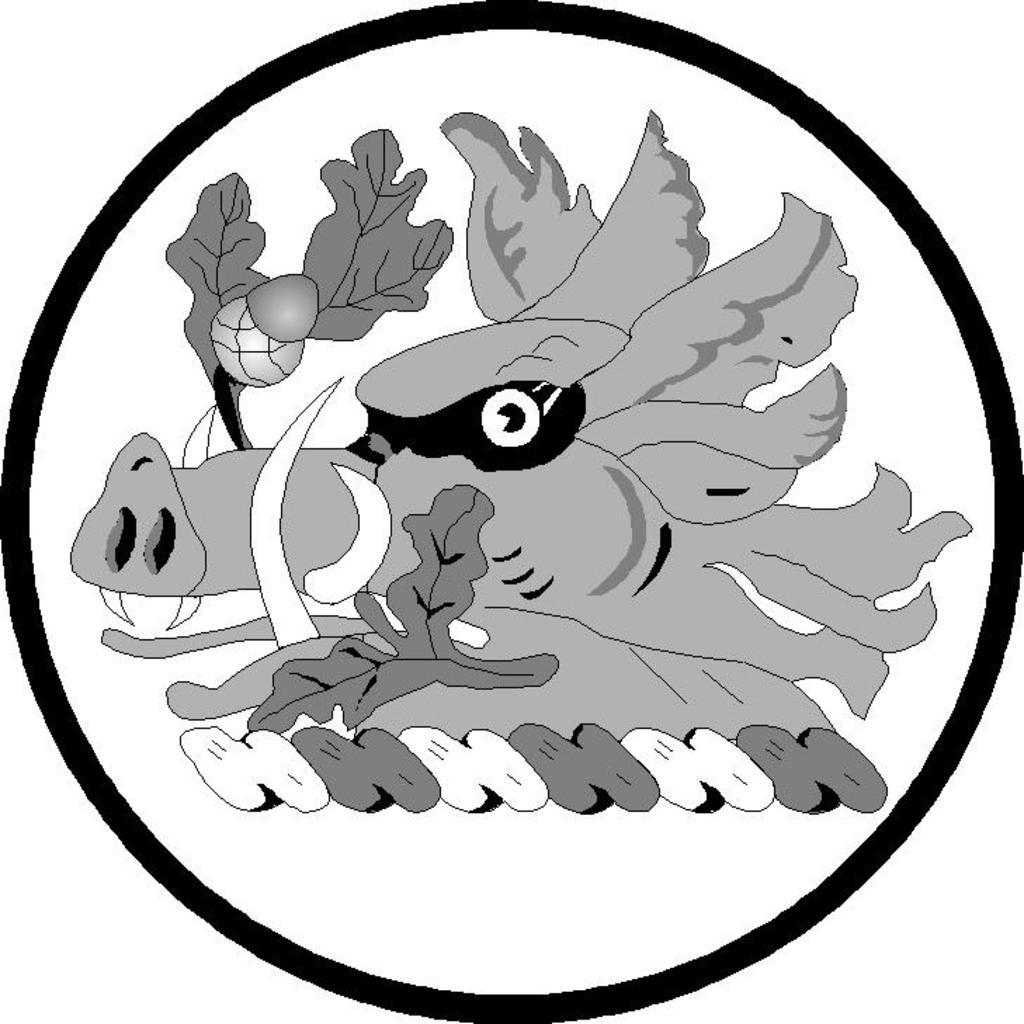What type of image is present in the picture? There is a cartoon image of an animal face in the image. What other elements can be seen in the image? Leaves are visible in the image. What type of paper is the animal face drawn on in the image? There is no paper mentioned in the image, as it is a cartoon image of an animal face. 